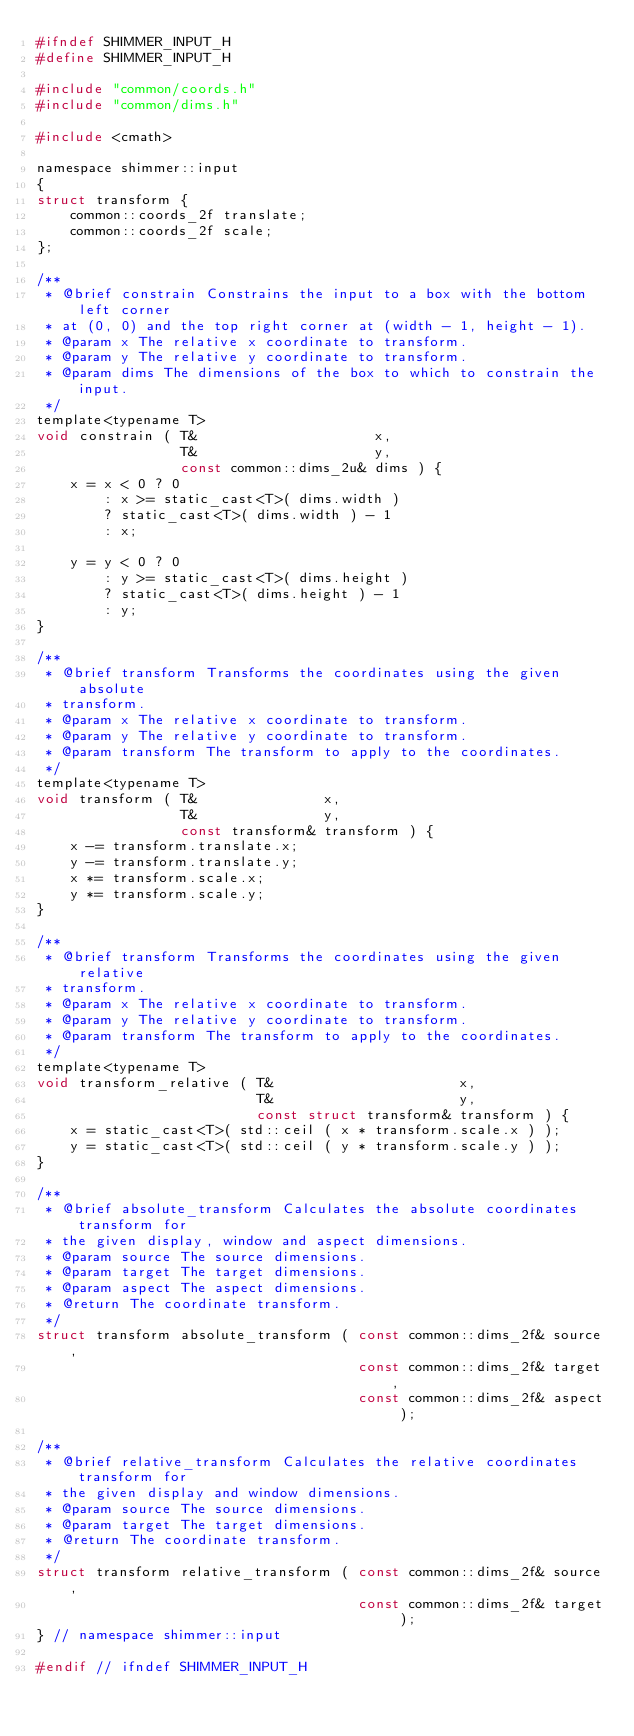Convert code to text. <code><loc_0><loc_0><loc_500><loc_500><_C_>#ifndef SHIMMER_INPUT_H
#define SHIMMER_INPUT_H

#include "common/coords.h"
#include "common/dims.h"

#include <cmath>

namespace shimmer::input
{
struct transform {
    common::coords_2f translate;
    common::coords_2f scale;
};

/**
 * @brief constrain Constrains the input to a box with the bottom left corner
 * at (0, 0) and the top right corner at (width - 1, height - 1).
 * @param x The relative x coordinate to transform.
 * @param y The relative y coordinate to transform.
 * @param dims The dimensions of the box to which to constrain the input.
 */
template<typename T>
void constrain ( T&                     x,
                 T&                     y,
                 const common::dims_2u& dims ) {
    x = x < 0 ? 0
        : x >= static_cast<T>( dims.width )
        ? static_cast<T>( dims.width ) - 1
        : x;

    y = y < 0 ? 0
        : y >= static_cast<T>( dims.height )
        ? static_cast<T>( dims.height ) - 1
        : y;
}

/**
 * @brief transform Transforms the coordinates using the given absolute
 * transform.
 * @param x The relative x coordinate to transform.
 * @param y The relative y coordinate to transform.
 * @param transform The transform to apply to the coordinates.
 */
template<typename T>
void transform ( T&               x,
                 T&               y,
                 const transform& transform ) {
    x -= transform.translate.x;
    y -= transform.translate.y;
    x *= transform.scale.x;
    y *= transform.scale.y;
}

/**
 * @brief transform Transforms the coordinates using the given relative
 * transform.
 * @param x The relative x coordinate to transform.
 * @param y The relative y coordinate to transform.
 * @param transform The transform to apply to the coordinates.
 */
template<typename T>
void transform_relative ( T&                      x,
                          T&                      y,
                          const struct transform& transform ) {
    x = static_cast<T>( std::ceil ( x * transform.scale.x ) );
    y = static_cast<T>( std::ceil ( y * transform.scale.y ) );
}

/**
 * @brief absolute_transform Calculates the absolute coordinates transform for
 * the given display, window and aspect dimensions.
 * @param source The source dimensions.
 * @param target The target dimensions.
 * @param aspect The aspect dimensions.
 * @return The coordinate transform.
 */
struct transform absolute_transform ( const common::dims_2f& source,
                                      const common::dims_2f& target,
                                      const common::dims_2f& aspect );

/**
 * @brief relative_transform Calculates the relative coordinates transform for
 * the given display and window dimensions.
 * @param source The source dimensions.
 * @param target The target dimensions.
 * @return The coordinate transform.
 */
struct transform relative_transform ( const common::dims_2f& source,
                                      const common::dims_2f& target );
} // namespace shimmer::input

#endif // ifndef SHIMMER_INPUT_H
</code> 